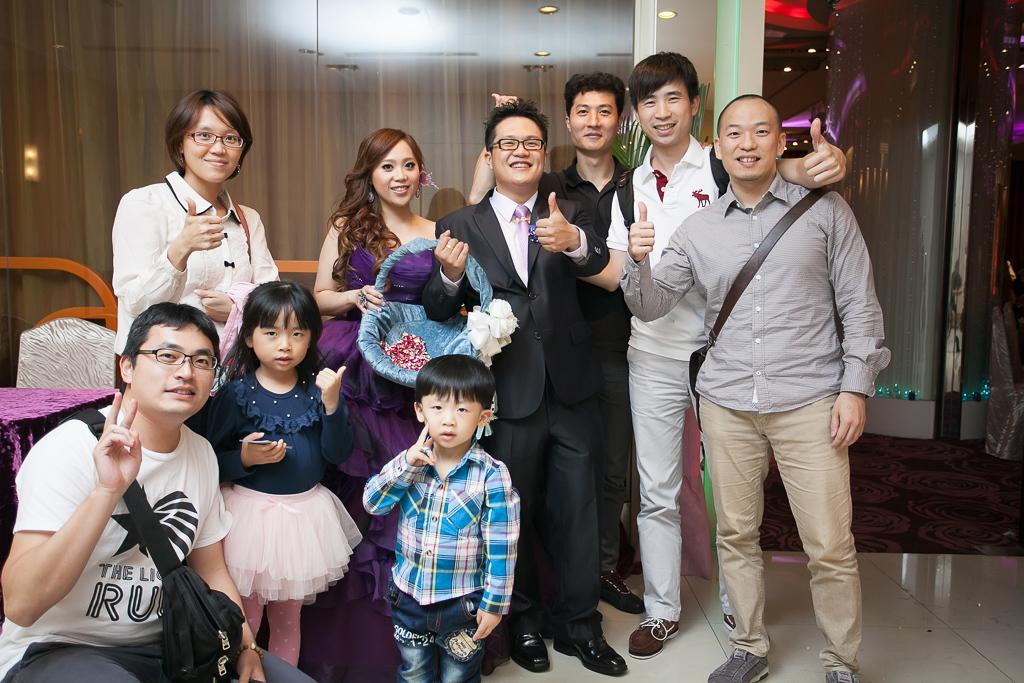What is happening in the image involving the group of people? The people in the image are smiling, which suggests they are enjoying themselves or having a good time. Can you describe the background of the image? There are lights and other objects visible in the background of the image. How many people are in the group? The number of people in the group is not specified, but there is a group of people present in the image. What type of drum is being played by the person in the image? There is no person playing a drum in the image; the people in the image are smiling and there are no musical instruments visible. 